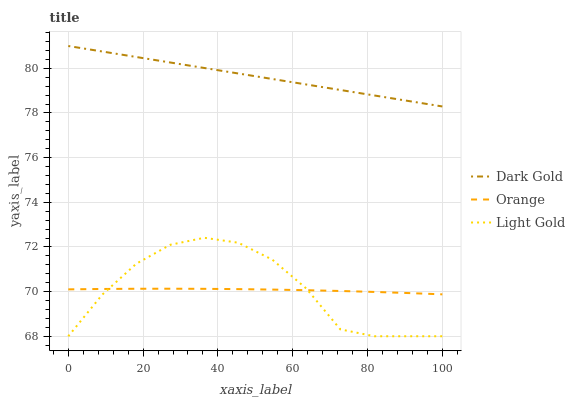Does Orange have the minimum area under the curve?
Answer yes or no. Yes. Does Dark Gold have the maximum area under the curve?
Answer yes or no. Yes. Does Light Gold have the minimum area under the curve?
Answer yes or no. No. Does Light Gold have the maximum area under the curve?
Answer yes or no. No. Is Dark Gold the smoothest?
Answer yes or no. Yes. Is Light Gold the roughest?
Answer yes or no. Yes. Is Light Gold the smoothest?
Answer yes or no. No. Is Dark Gold the roughest?
Answer yes or no. No. Does Light Gold have the lowest value?
Answer yes or no. Yes. Does Dark Gold have the lowest value?
Answer yes or no. No. Does Dark Gold have the highest value?
Answer yes or no. Yes. Does Light Gold have the highest value?
Answer yes or no. No. Is Light Gold less than Dark Gold?
Answer yes or no. Yes. Is Dark Gold greater than Orange?
Answer yes or no. Yes. Does Light Gold intersect Orange?
Answer yes or no. Yes. Is Light Gold less than Orange?
Answer yes or no. No. Is Light Gold greater than Orange?
Answer yes or no. No. Does Light Gold intersect Dark Gold?
Answer yes or no. No. 